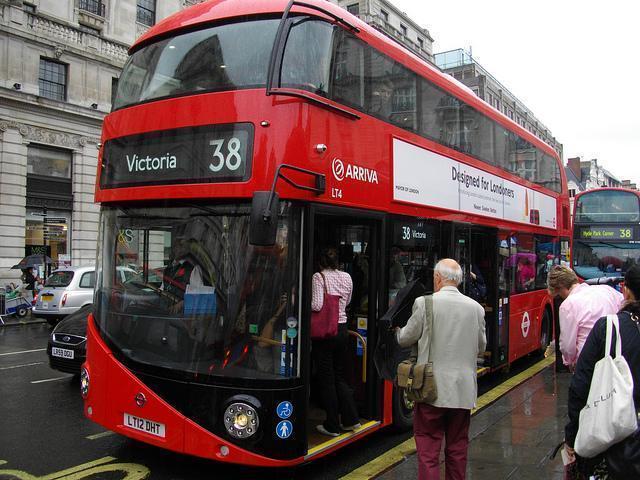What are these people waiting to do?
Make your selection from the four choices given to correctly answer the question.
Options: Board bus, see show, shop sale, get treatment. Board bus. 